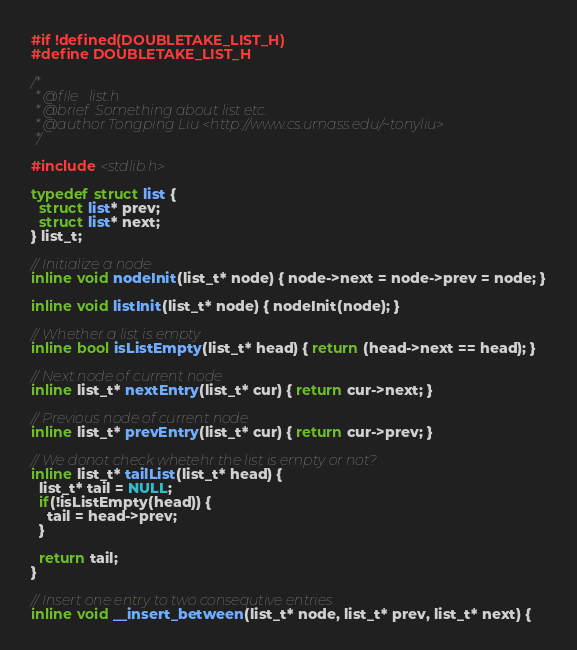Convert code to text. <code><loc_0><loc_0><loc_500><loc_500><_C++_>#if !defined(DOUBLETAKE_LIST_H)
#define DOUBLETAKE_LIST_H

/*
 * @file   list.h
 * @brief  Something about list etc.
 * @author Tongping Liu <http://www.cs.umass.edu/~tonyliu>
 */

#include <stdlib.h>

typedef struct list {
  struct list* prev;
  struct list* next;
} list_t;

// Initialize a node
inline void nodeInit(list_t* node) { node->next = node->prev = node; }

inline void listInit(list_t* node) { nodeInit(node); }

// Whether a list is empty
inline bool isListEmpty(list_t* head) { return (head->next == head); }

// Next node of current node
inline list_t* nextEntry(list_t* cur) { return cur->next; }

// Previous node of current node
inline list_t* prevEntry(list_t* cur) { return cur->prev; }

// We donot check whetehr the list is empty or not?
inline list_t* tailList(list_t* head) {
  list_t* tail = NULL;
  if(!isListEmpty(head)) {
    tail = head->prev;
  }

  return tail;
}

// Insert one entry to two consequtive entries
inline void __insert_between(list_t* node, list_t* prev, list_t* next) {</code> 